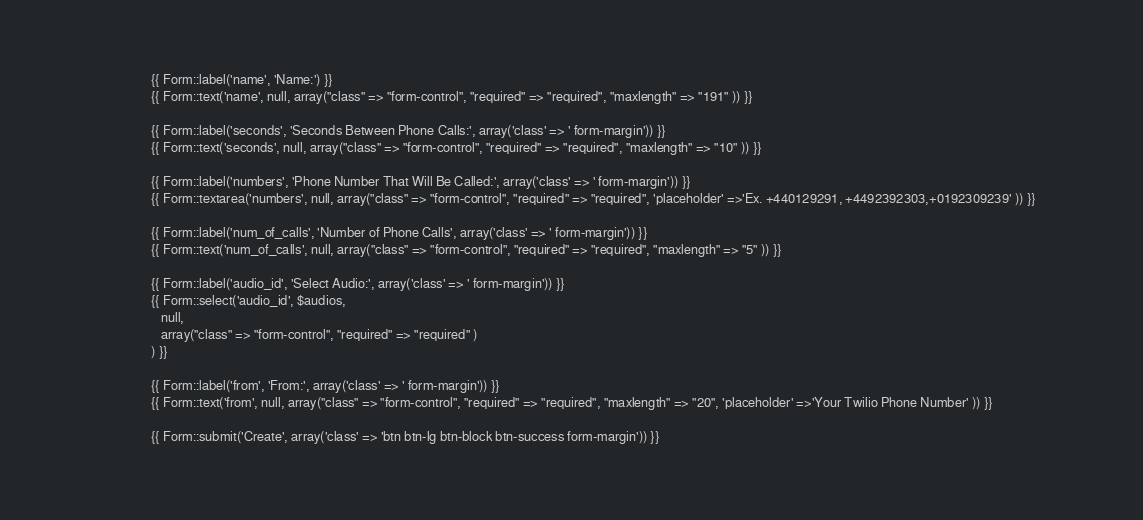<code> <loc_0><loc_0><loc_500><loc_500><_PHP_>					    {{ Form::label('name', 'Name:') }}
					    {{ Form::text('name', null, array("class" => "form-control", "required" => "required", "maxlength" => "191" )) }}

					    {{ Form::label('seconds', 'Seconds Between Phone Calls:', array('class' => ' form-margin')) }}
					    {{ Form::text('seconds', null, array("class" => "form-control", "required" => "required", "maxlength" => "10" )) }}

					    {{ Form::label('numbers', 'Phone Number That Will Be Called:', array('class' => ' form-margin')) }}
					    {{ Form::textarea('numbers', null, array("class" => "form-control", "required" => "required", 'placeholder' =>'Ex. +440129291, +4492392303,+0192309239' )) }}

					    {{ Form::label('num_of_calls', 'Number of Phone Calls', array('class' => ' form-margin')) }}
					    {{ Form::text('num_of_calls', null, array("class" => "form-control", "required" => "required", "maxlength" => "5" )) }}

					    {{ Form::label('audio_id', 'Select Audio:', array('class' => ' form-margin')) }}
					    {{ Form::select('audio_id', $audios,
						   null,
						   array("class" => "form-control", "required" => "required" ) 
						) }}

						{{ Form::label('from', 'From:', array('class' => ' form-margin')) }}
					    {{ Form::text('from', null, array("class" => "form-control", "required" => "required", "maxlength" => "20", 'placeholder' =>'Your Twilio Phone Number' )) }}						

					    {{ Form::submit('Create', array('class' => 'btn btn-lg btn-block btn-success form-margin')) }}
</code> 